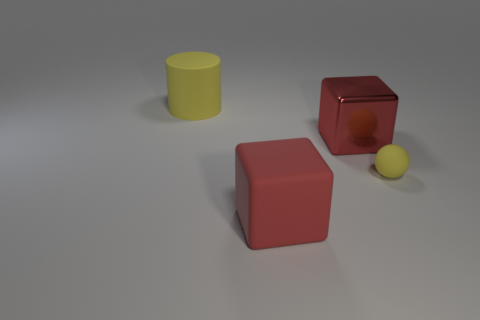Add 4 big red things. How many objects exist? 8 Subtract all balls. How many objects are left? 3 Subtract 0 brown blocks. How many objects are left? 4 Subtract all large red objects. Subtract all big metallic cylinders. How many objects are left? 2 Add 3 large yellow cylinders. How many large yellow cylinders are left? 4 Add 1 tiny gray matte objects. How many tiny gray matte objects exist? 1 